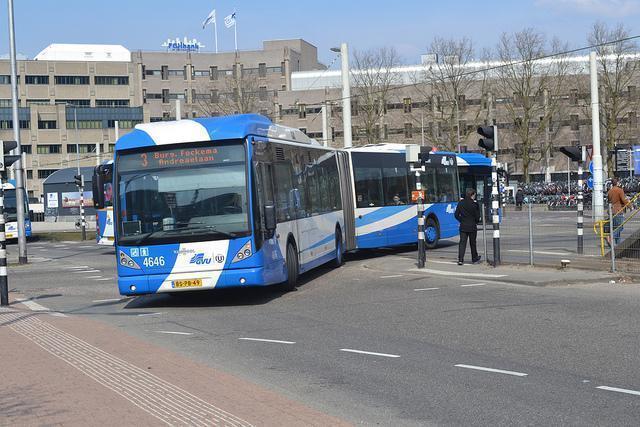What style design connects the two bus parts here?
Select the correct answer and articulate reasoning with the following format: 'Answer: answer
Rationale: rationale.'
Options: Invisible, bolts, accordion, rope. Answer: accordion.
Rationale: Two buses are connected by a section in the middle. 